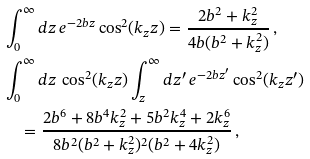<formula> <loc_0><loc_0><loc_500><loc_500>& \int _ { 0 } ^ { \infty } d z \, e ^ { - 2 b z } \cos ^ { 2 } ( k _ { z } z ) = \frac { 2 b ^ { 2 } + k _ { z } ^ { 2 } } { 4 b ( b ^ { 2 } + k _ { z } ^ { 2 } ) } \, , \\ & \int _ { 0 } ^ { \infty } d z \, \cos ^ { 2 } ( k _ { z } z ) \int _ { z } ^ { \infty } d z ^ { \prime } \, e ^ { - 2 b z ^ { \prime } } \cos ^ { 2 } ( k _ { z } z ^ { \prime } ) \\ & \quad = \frac { 2 b ^ { 6 } + 8 b ^ { 4 } k _ { z } ^ { 2 } + 5 b ^ { 2 } k _ { z } ^ { 4 } + 2 k _ { z } ^ { 6 } } { 8 b ^ { 2 } ( b ^ { 2 } + k _ { z } ^ { 2 } ) ^ { 2 } ( b ^ { 2 } + 4 k _ { z } ^ { 2 } ) } \, ,</formula> 